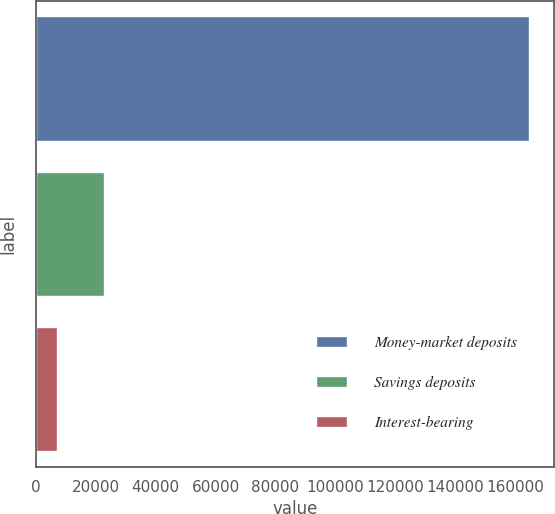Convert chart. <chart><loc_0><loc_0><loc_500><loc_500><bar_chart><fcel>Money-market deposits<fcel>Savings deposits<fcel>Interest-bearing<nl><fcel>164734<fcel>22725.7<fcel>6947<nl></chart> 